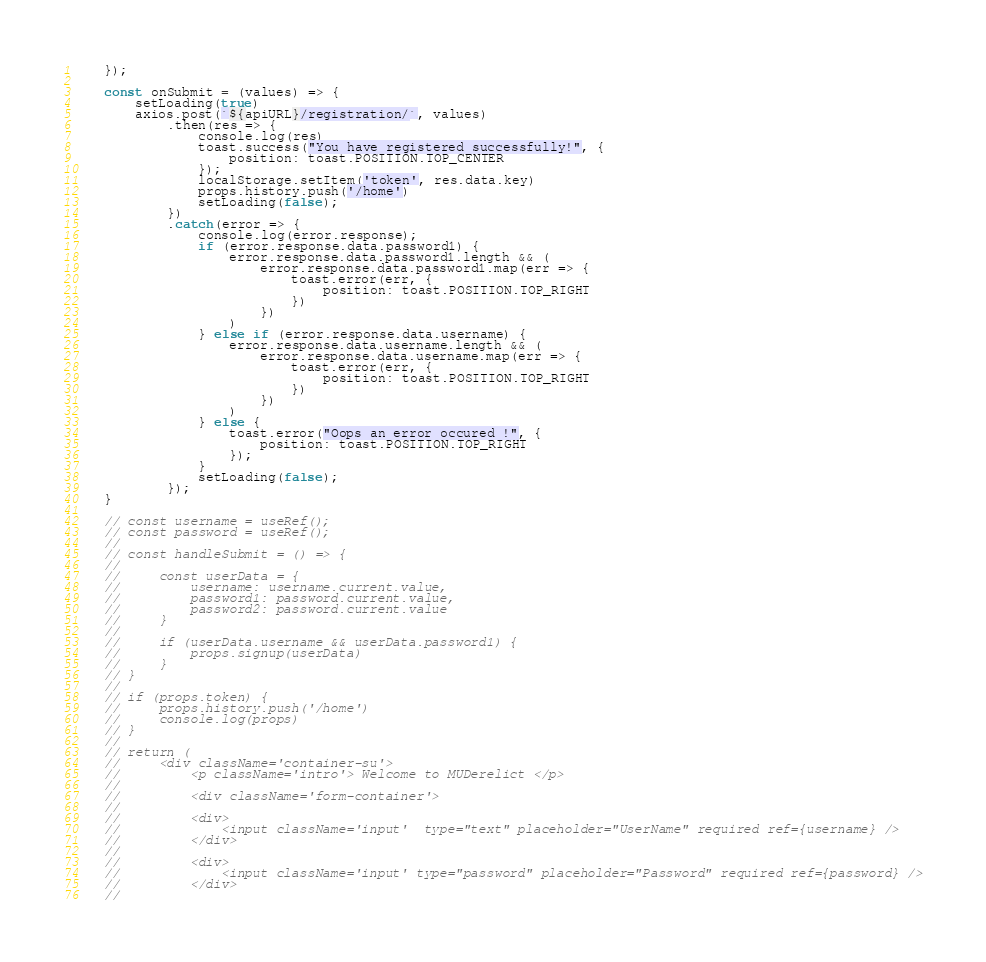<code> <loc_0><loc_0><loc_500><loc_500><_JavaScript_>
    });

    const onSubmit = (values) => {
        setLoading(true)
        axios.post(`${apiURL}/registration/`, values)
            .then(res => {
                console.log(res)
                toast.success("You have registered successfully!", {
                    position: toast.POSITION.TOP_CENTER
                });
                localStorage.setItem('token', res.data.key)
                props.history.push('/home')
                setLoading(false);
            })
            .catch(error => {
                console.log(error.response);
                if (error.response.data.password1) {
                    error.response.data.password1.length && (
                        error.response.data.password1.map(err => {
                            toast.error(err, {
                                position: toast.POSITION.TOP_RIGHT
                            })
                        })
                    )
                } else if (error.response.data.username) {
                    error.response.data.username.length && (
                        error.response.data.username.map(err => {
                            toast.error(err, {
                                position: toast.POSITION.TOP_RIGHT
                            })
                        })
                    )
                } else {
                    toast.error("Oops an error occured !", {
                        position: toast.POSITION.TOP_RIGHT
                    });
                }
                setLoading(false);
            });
    }

    // const username = useRef();
    // const password = useRef();
    //
    // const handleSubmit = () => {
    //
    //     const userData = {
    //         username: username.current.value,
    //         password1: password.current.value,
    //         password2: password.current.value
    //     }
    //
    //     if (userData.username && userData.password1) {
    //         props.signup(userData)
    //     }
    // }
    //
    // if (props.token) {
    //     props.history.push('/home')
    //     console.log(props)
    // }
    //
    // return (
    //     <div className='container-su'>
    //         <p className='intro'> Welcome to MUDerelict </p>
    //
    //         <div className='form-container'>
    //
    //         <div>
    //             <input className='input'  type="text" placeholder="UserName" required ref={username} />
    //         </div>
    //
    //         <div>
    //             <input className='input' type="password" placeholder="Password" required ref={password} />
    //         </div>
    //</code> 